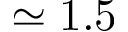Convert formula to latex. <formula><loc_0><loc_0><loc_500><loc_500>\simeq 1 . 5</formula> 